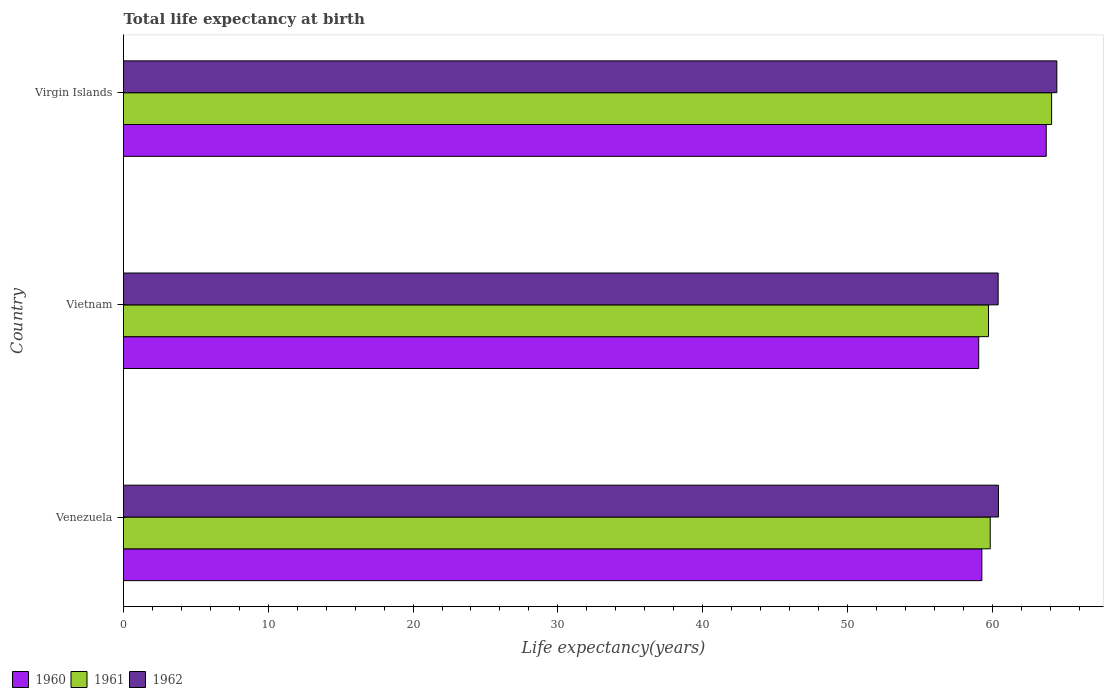How many different coloured bars are there?
Offer a very short reply. 3. How many groups of bars are there?
Ensure brevity in your answer.  3. Are the number of bars per tick equal to the number of legend labels?
Keep it short and to the point. Yes. How many bars are there on the 1st tick from the top?
Provide a short and direct response. 3. What is the label of the 3rd group of bars from the top?
Ensure brevity in your answer.  Venezuela. What is the life expectancy at birth in in 1962 in Virgin Islands?
Your answer should be compact. 64.46. Across all countries, what is the maximum life expectancy at birth in in 1960?
Your answer should be compact. 63.73. Across all countries, what is the minimum life expectancy at birth in in 1960?
Provide a succinct answer. 59.07. In which country was the life expectancy at birth in in 1962 maximum?
Your answer should be very brief. Virgin Islands. In which country was the life expectancy at birth in in 1961 minimum?
Make the answer very short. Vietnam. What is the total life expectancy at birth in in 1960 in the graph?
Ensure brevity in your answer.  182.08. What is the difference between the life expectancy at birth in in 1960 in Venezuela and that in Vietnam?
Provide a short and direct response. 0.22. What is the difference between the life expectancy at birth in in 1960 in Virgin Islands and the life expectancy at birth in in 1961 in Vietnam?
Your answer should be very brief. 3.99. What is the average life expectancy at birth in in 1962 per country?
Offer a very short reply. 61.77. What is the difference between the life expectancy at birth in in 1962 and life expectancy at birth in in 1961 in Vietnam?
Ensure brevity in your answer.  0.67. In how many countries, is the life expectancy at birth in in 1961 greater than 42 years?
Ensure brevity in your answer.  3. What is the ratio of the life expectancy at birth in in 1961 in Vietnam to that in Virgin Islands?
Keep it short and to the point. 0.93. Is the difference between the life expectancy at birth in in 1962 in Venezuela and Virgin Islands greater than the difference between the life expectancy at birth in in 1961 in Venezuela and Virgin Islands?
Make the answer very short. Yes. What is the difference between the highest and the second highest life expectancy at birth in in 1962?
Keep it short and to the point. 4.03. What is the difference between the highest and the lowest life expectancy at birth in in 1961?
Offer a very short reply. 4.36. In how many countries, is the life expectancy at birth in in 1960 greater than the average life expectancy at birth in in 1960 taken over all countries?
Your answer should be very brief. 1. What does the 3rd bar from the top in Vietnam represents?
Keep it short and to the point. 1960. Is it the case that in every country, the sum of the life expectancy at birth in in 1960 and life expectancy at birth in in 1961 is greater than the life expectancy at birth in in 1962?
Offer a very short reply. Yes. How many bars are there?
Ensure brevity in your answer.  9. Are all the bars in the graph horizontal?
Your answer should be compact. Yes. How many countries are there in the graph?
Your answer should be compact. 3. What is the difference between two consecutive major ticks on the X-axis?
Keep it short and to the point. 10. Are the values on the major ticks of X-axis written in scientific E-notation?
Your answer should be compact. No. How many legend labels are there?
Keep it short and to the point. 3. What is the title of the graph?
Give a very brief answer. Total life expectancy at birth. Does "1987" appear as one of the legend labels in the graph?
Give a very brief answer. No. What is the label or title of the X-axis?
Ensure brevity in your answer.  Life expectancy(years). What is the label or title of the Y-axis?
Your answer should be very brief. Country. What is the Life expectancy(years) of 1960 in Venezuela?
Provide a short and direct response. 59.29. What is the Life expectancy(years) of 1961 in Venezuela?
Provide a succinct answer. 59.86. What is the Life expectancy(years) in 1962 in Venezuela?
Offer a terse response. 60.43. What is the Life expectancy(years) of 1960 in Vietnam?
Your answer should be compact. 59.07. What is the Life expectancy(years) in 1961 in Vietnam?
Ensure brevity in your answer.  59.74. What is the Life expectancy(years) in 1962 in Vietnam?
Keep it short and to the point. 60.41. What is the Life expectancy(years) in 1960 in Virgin Islands?
Make the answer very short. 63.73. What is the Life expectancy(years) in 1961 in Virgin Islands?
Your answer should be very brief. 64.1. What is the Life expectancy(years) in 1962 in Virgin Islands?
Make the answer very short. 64.46. Across all countries, what is the maximum Life expectancy(years) of 1960?
Your response must be concise. 63.73. Across all countries, what is the maximum Life expectancy(years) in 1961?
Keep it short and to the point. 64.1. Across all countries, what is the maximum Life expectancy(years) in 1962?
Offer a terse response. 64.46. Across all countries, what is the minimum Life expectancy(years) of 1960?
Provide a short and direct response. 59.07. Across all countries, what is the minimum Life expectancy(years) of 1961?
Offer a terse response. 59.74. Across all countries, what is the minimum Life expectancy(years) in 1962?
Provide a succinct answer. 60.41. What is the total Life expectancy(years) in 1960 in the graph?
Your answer should be compact. 182.08. What is the total Life expectancy(years) of 1961 in the graph?
Your response must be concise. 183.71. What is the total Life expectancy(years) in 1962 in the graph?
Offer a terse response. 185.3. What is the difference between the Life expectancy(years) in 1960 in Venezuela and that in Vietnam?
Keep it short and to the point. 0.22. What is the difference between the Life expectancy(years) in 1961 in Venezuela and that in Vietnam?
Make the answer very short. 0.12. What is the difference between the Life expectancy(years) in 1962 in Venezuela and that in Vietnam?
Your answer should be compact. 0.02. What is the difference between the Life expectancy(years) in 1960 in Venezuela and that in Virgin Islands?
Provide a short and direct response. -4.45. What is the difference between the Life expectancy(years) of 1961 in Venezuela and that in Virgin Islands?
Your response must be concise. -4.24. What is the difference between the Life expectancy(years) of 1962 in Venezuela and that in Virgin Islands?
Provide a succinct answer. -4.03. What is the difference between the Life expectancy(years) of 1960 in Vietnam and that in Virgin Islands?
Give a very brief answer. -4.66. What is the difference between the Life expectancy(years) in 1961 in Vietnam and that in Virgin Islands?
Keep it short and to the point. -4.36. What is the difference between the Life expectancy(years) in 1962 in Vietnam and that in Virgin Islands?
Provide a short and direct response. -4.05. What is the difference between the Life expectancy(years) of 1960 in Venezuela and the Life expectancy(years) of 1961 in Vietnam?
Keep it short and to the point. -0.46. What is the difference between the Life expectancy(years) in 1960 in Venezuela and the Life expectancy(years) in 1962 in Vietnam?
Your answer should be compact. -1.13. What is the difference between the Life expectancy(years) in 1961 in Venezuela and the Life expectancy(years) in 1962 in Vietnam?
Offer a very short reply. -0.55. What is the difference between the Life expectancy(years) in 1960 in Venezuela and the Life expectancy(years) in 1961 in Virgin Islands?
Provide a succinct answer. -4.82. What is the difference between the Life expectancy(years) in 1960 in Venezuela and the Life expectancy(years) in 1962 in Virgin Islands?
Offer a very short reply. -5.18. What is the difference between the Life expectancy(years) in 1960 in Vietnam and the Life expectancy(years) in 1961 in Virgin Islands?
Give a very brief answer. -5.03. What is the difference between the Life expectancy(years) in 1960 in Vietnam and the Life expectancy(years) in 1962 in Virgin Islands?
Provide a succinct answer. -5.4. What is the difference between the Life expectancy(years) in 1961 in Vietnam and the Life expectancy(years) in 1962 in Virgin Islands?
Offer a terse response. -4.72. What is the average Life expectancy(years) in 1960 per country?
Your answer should be very brief. 60.69. What is the average Life expectancy(years) in 1961 per country?
Keep it short and to the point. 61.24. What is the average Life expectancy(years) in 1962 per country?
Offer a very short reply. 61.77. What is the difference between the Life expectancy(years) of 1960 and Life expectancy(years) of 1961 in Venezuela?
Make the answer very short. -0.58. What is the difference between the Life expectancy(years) in 1960 and Life expectancy(years) in 1962 in Venezuela?
Your answer should be compact. -1.15. What is the difference between the Life expectancy(years) in 1961 and Life expectancy(years) in 1962 in Venezuela?
Make the answer very short. -0.57. What is the difference between the Life expectancy(years) in 1960 and Life expectancy(years) in 1961 in Vietnam?
Give a very brief answer. -0.68. What is the difference between the Life expectancy(years) in 1960 and Life expectancy(years) in 1962 in Vietnam?
Provide a succinct answer. -1.34. What is the difference between the Life expectancy(years) of 1961 and Life expectancy(years) of 1962 in Vietnam?
Provide a short and direct response. -0.67. What is the difference between the Life expectancy(years) in 1960 and Life expectancy(years) in 1961 in Virgin Islands?
Give a very brief answer. -0.37. What is the difference between the Life expectancy(years) of 1960 and Life expectancy(years) of 1962 in Virgin Islands?
Provide a succinct answer. -0.73. What is the difference between the Life expectancy(years) in 1961 and Life expectancy(years) in 1962 in Virgin Islands?
Your answer should be very brief. -0.36. What is the ratio of the Life expectancy(years) of 1961 in Venezuela to that in Vietnam?
Your answer should be very brief. 1. What is the ratio of the Life expectancy(years) in 1960 in Venezuela to that in Virgin Islands?
Keep it short and to the point. 0.93. What is the ratio of the Life expectancy(years) of 1961 in Venezuela to that in Virgin Islands?
Make the answer very short. 0.93. What is the ratio of the Life expectancy(years) in 1962 in Venezuela to that in Virgin Islands?
Make the answer very short. 0.94. What is the ratio of the Life expectancy(years) of 1960 in Vietnam to that in Virgin Islands?
Provide a succinct answer. 0.93. What is the ratio of the Life expectancy(years) in 1961 in Vietnam to that in Virgin Islands?
Your answer should be compact. 0.93. What is the ratio of the Life expectancy(years) in 1962 in Vietnam to that in Virgin Islands?
Offer a terse response. 0.94. What is the difference between the highest and the second highest Life expectancy(years) in 1960?
Your answer should be compact. 4.45. What is the difference between the highest and the second highest Life expectancy(years) of 1961?
Give a very brief answer. 4.24. What is the difference between the highest and the second highest Life expectancy(years) in 1962?
Give a very brief answer. 4.03. What is the difference between the highest and the lowest Life expectancy(years) in 1960?
Offer a terse response. 4.66. What is the difference between the highest and the lowest Life expectancy(years) of 1961?
Your response must be concise. 4.36. What is the difference between the highest and the lowest Life expectancy(years) in 1962?
Give a very brief answer. 4.05. 